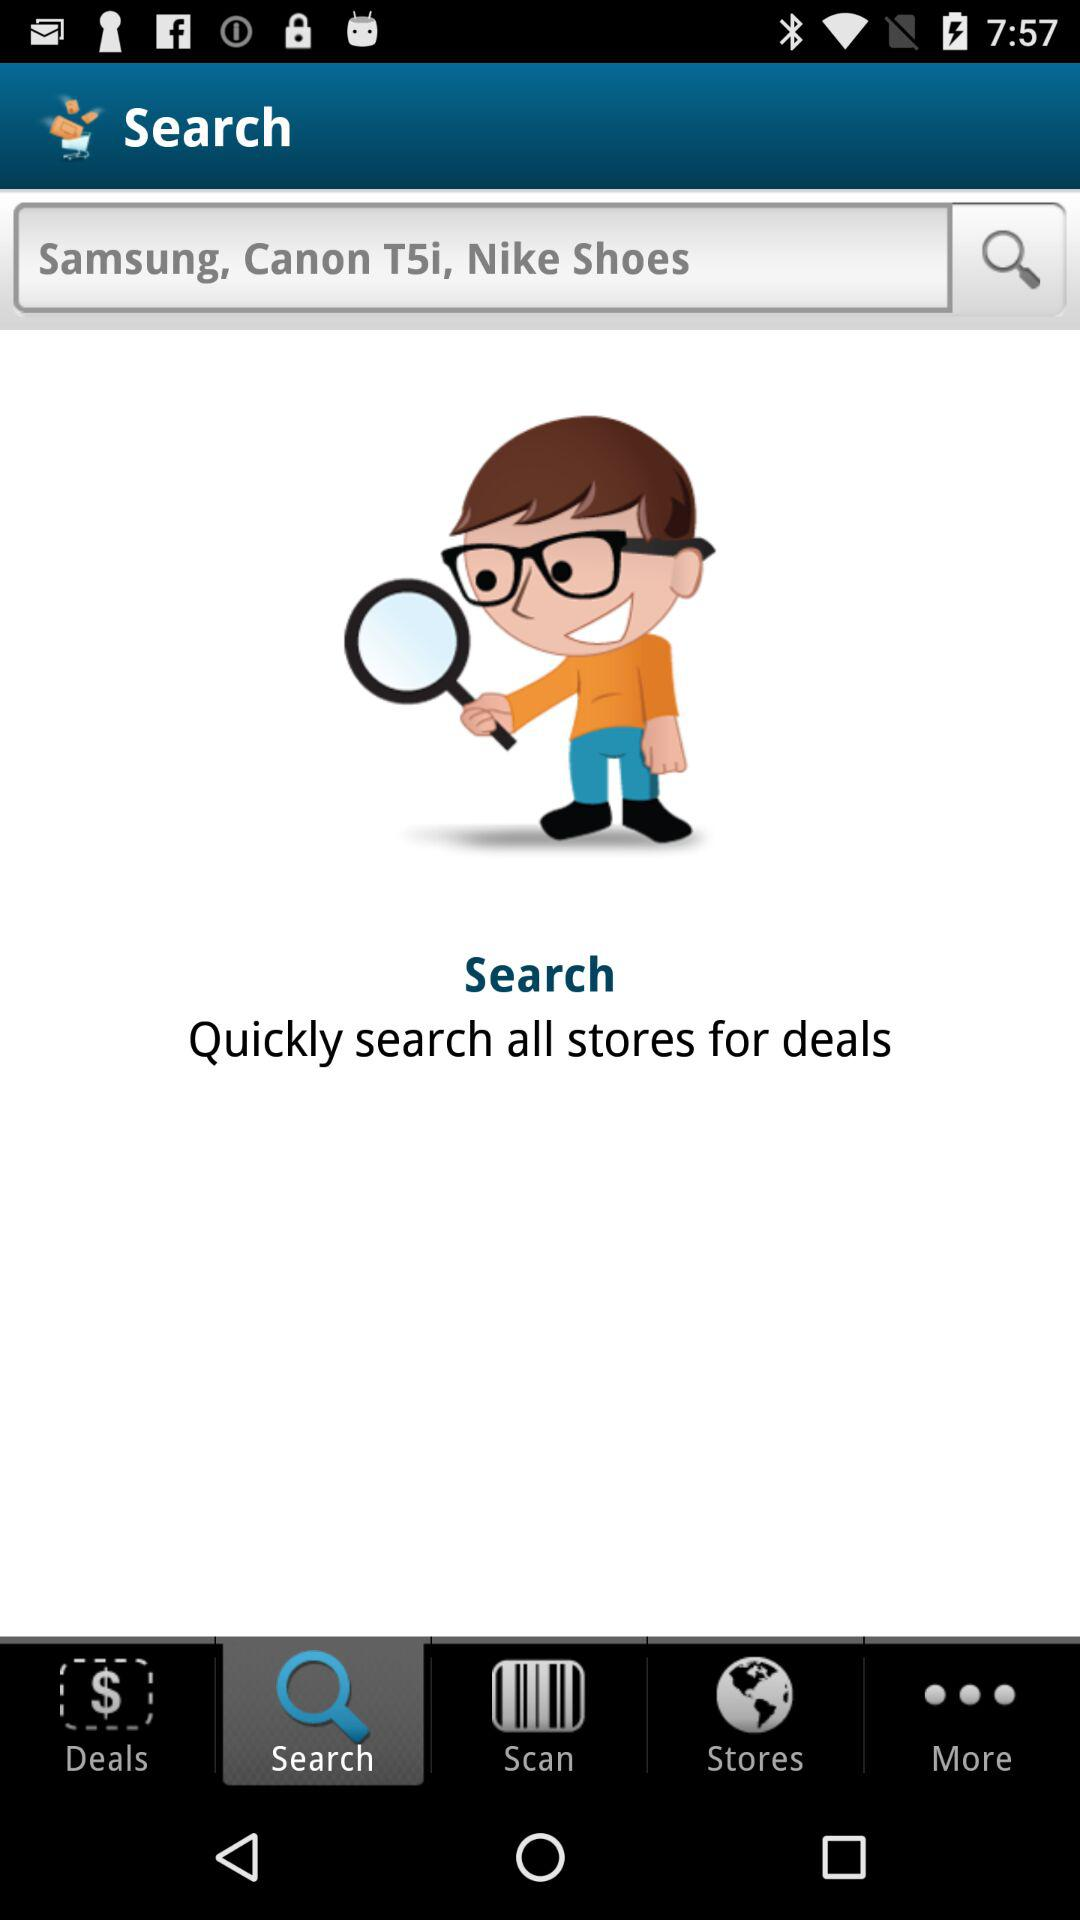Which tab is selected? The selected tab is "Search". 